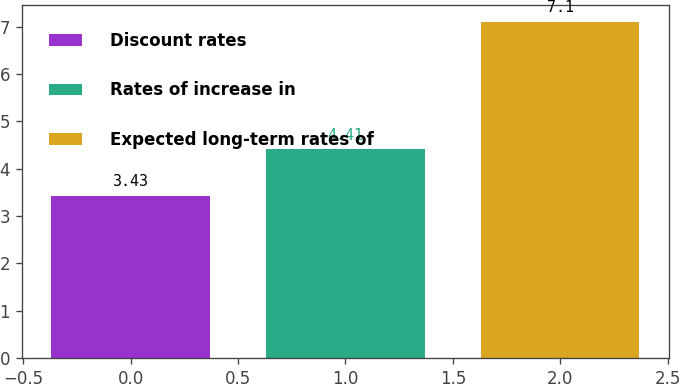<chart> <loc_0><loc_0><loc_500><loc_500><bar_chart><fcel>Discount rates<fcel>Rates of increase in<fcel>Expected long-term rates of<nl><fcel>3.43<fcel>4.41<fcel>7.1<nl></chart> 